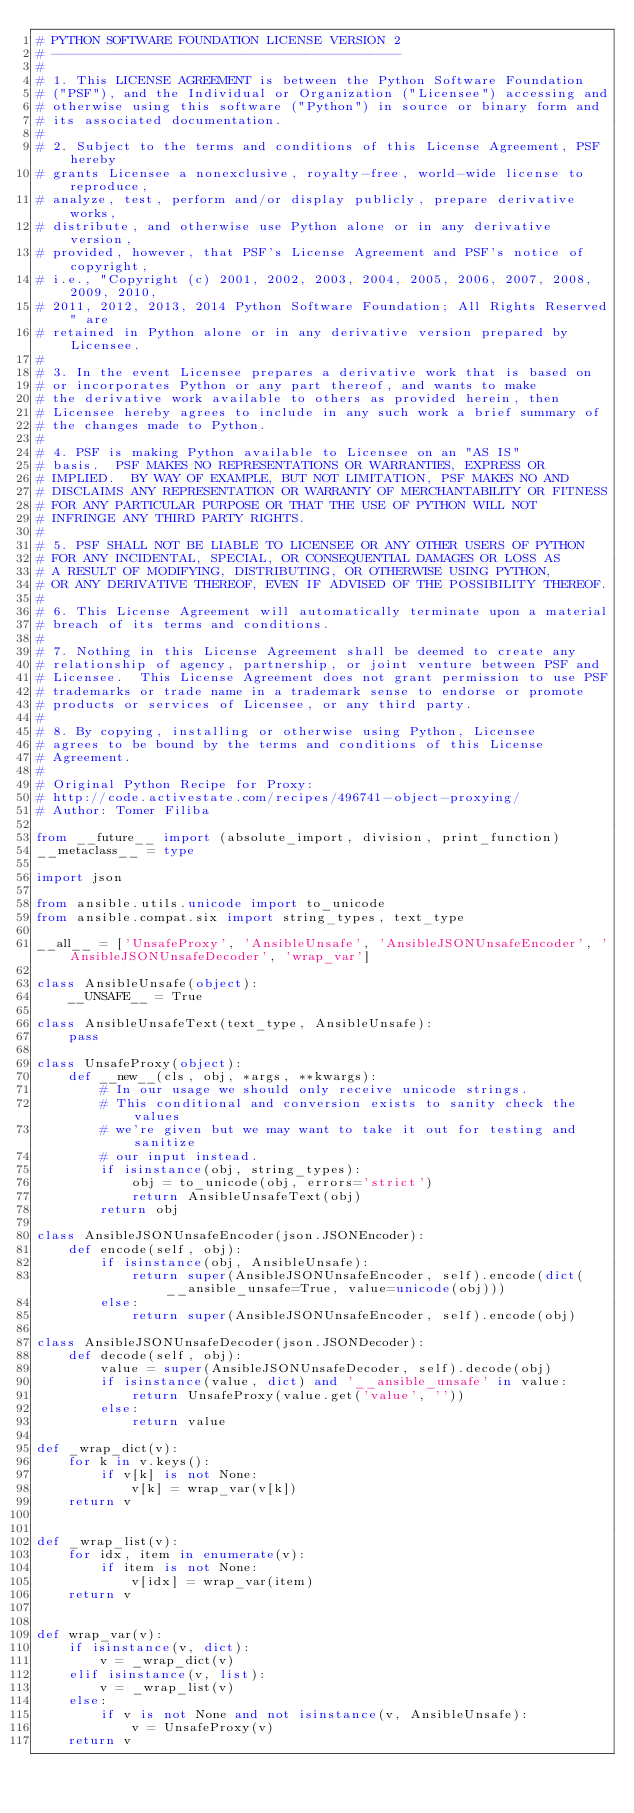<code> <loc_0><loc_0><loc_500><loc_500><_Python_># PYTHON SOFTWARE FOUNDATION LICENSE VERSION 2
# --------------------------------------------
#
# 1. This LICENSE AGREEMENT is between the Python Software Foundation
# ("PSF"), and the Individual or Organization ("Licensee") accessing and
# otherwise using this software ("Python") in source or binary form and
# its associated documentation.
#
# 2. Subject to the terms and conditions of this License Agreement, PSF hereby
# grants Licensee a nonexclusive, royalty-free, world-wide license to reproduce,
# analyze, test, perform and/or display publicly, prepare derivative works,
# distribute, and otherwise use Python alone or in any derivative version,
# provided, however, that PSF's License Agreement and PSF's notice of copyright,
# i.e., "Copyright (c) 2001, 2002, 2003, 2004, 2005, 2006, 2007, 2008, 2009, 2010,
# 2011, 2012, 2013, 2014 Python Software Foundation; All Rights Reserved" are
# retained in Python alone or in any derivative version prepared by Licensee.
#
# 3. In the event Licensee prepares a derivative work that is based on
# or incorporates Python or any part thereof, and wants to make
# the derivative work available to others as provided herein, then
# Licensee hereby agrees to include in any such work a brief summary of
# the changes made to Python.
#
# 4. PSF is making Python available to Licensee on an "AS IS"
# basis.  PSF MAKES NO REPRESENTATIONS OR WARRANTIES, EXPRESS OR
# IMPLIED.  BY WAY OF EXAMPLE, BUT NOT LIMITATION, PSF MAKES NO AND
# DISCLAIMS ANY REPRESENTATION OR WARRANTY OF MERCHANTABILITY OR FITNESS
# FOR ANY PARTICULAR PURPOSE OR THAT THE USE OF PYTHON WILL NOT
# INFRINGE ANY THIRD PARTY RIGHTS.
#
# 5. PSF SHALL NOT BE LIABLE TO LICENSEE OR ANY OTHER USERS OF PYTHON
# FOR ANY INCIDENTAL, SPECIAL, OR CONSEQUENTIAL DAMAGES OR LOSS AS
# A RESULT OF MODIFYING, DISTRIBUTING, OR OTHERWISE USING PYTHON,
# OR ANY DERIVATIVE THEREOF, EVEN IF ADVISED OF THE POSSIBILITY THEREOF.
#
# 6. This License Agreement will automatically terminate upon a material
# breach of its terms and conditions.
#
# 7. Nothing in this License Agreement shall be deemed to create any
# relationship of agency, partnership, or joint venture between PSF and
# Licensee.  This License Agreement does not grant permission to use PSF
# trademarks or trade name in a trademark sense to endorse or promote
# products or services of Licensee, or any third party.
#
# 8. By copying, installing or otherwise using Python, Licensee
# agrees to be bound by the terms and conditions of this License
# Agreement.
#
# Original Python Recipe for Proxy:
# http://code.activestate.com/recipes/496741-object-proxying/
# Author: Tomer Filiba

from __future__ import (absolute_import, division, print_function)
__metaclass__ = type

import json

from ansible.utils.unicode import to_unicode
from ansible.compat.six import string_types, text_type

__all__ = ['UnsafeProxy', 'AnsibleUnsafe', 'AnsibleJSONUnsafeEncoder', 'AnsibleJSONUnsafeDecoder', 'wrap_var']

class AnsibleUnsafe(object):
    __UNSAFE__ = True

class AnsibleUnsafeText(text_type, AnsibleUnsafe):
    pass

class UnsafeProxy(object):
    def __new__(cls, obj, *args, **kwargs):
        # In our usage we should only receive unicode strings.
        # This conditional and conversion exists to sanity check the values
        # we're given but we may want to take it out for testing and sanitize
        # our input instead.
        if isinstance(obj, string_types):
            obj = to_unicode(obj, errors='strict')
            return AnsibleUnsafeText(obj)
        return obj

class AnsibleJSONUnsafeEncoder(json.JSONEncoder):
    def encode(self, obj):
        if isinstance(obj, AnsibleUnsafe):
            return super(AnsibleJSONUnsafeEncoder, self).encode(dict(__ansible_unsafe=True, value=unicode(obj)))
        else:
            return super(AnsibleJSONUnsafeEncoder, self).encode(obj)

class AnsibleJSONUnsafeDecoder(json.JSONDecoder):
    def decode(self, obj):
        value = super(AnsibleJSONUnsafeDecoder, self).decode(obj)
        if isinstance(value, dict) and '__ansible_unsafe' in value:
            return UnsafeProxy(value.get('value', ''))
        else:
            return value

def _wrap_dict(v):
    for k in v.keys():
        if v[k] is not None:
            v[k] = wrap_var(v[k])
    return v


def _wrap_list(v):
    for idx, item in enumerate(v):
        if item is not None:
            v[idx] = wrap_var(item)
    return v


def wrap_var(v):
    if isinstance(v, dict):
        v = _wrap_dict(v)
    elif isinstance(v, list):
        v = _wrap_list(v)
    else:
        if v is not None and not isinstance(v, AnsibleUnsafe):
            v = UnsafeProxy(v)
    return v

</code> 